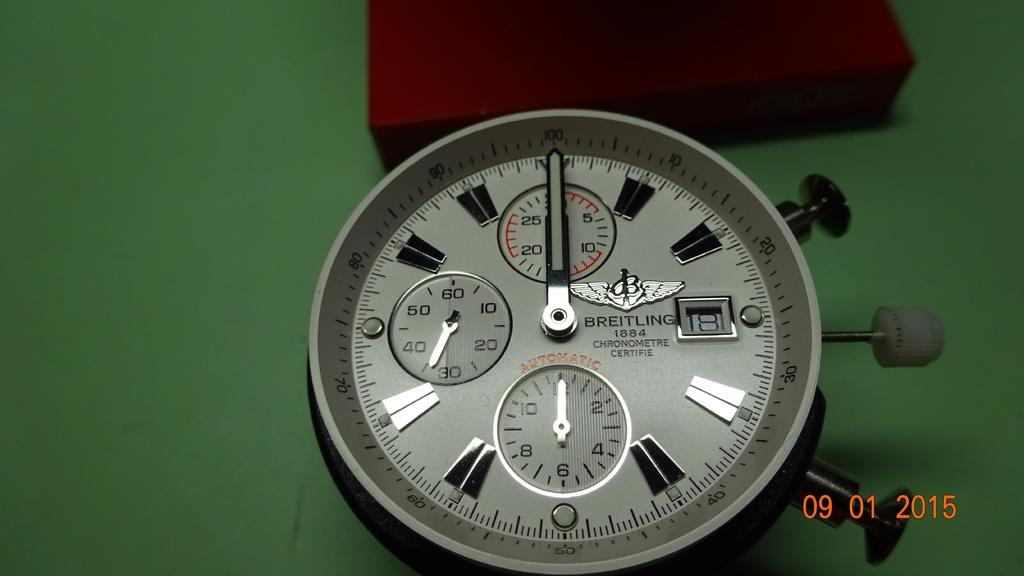<image>
Give a short and clear explanation of the subsequent image. A Breitling stop watch with 3 knobs is on a  green table in front of a brown box. 